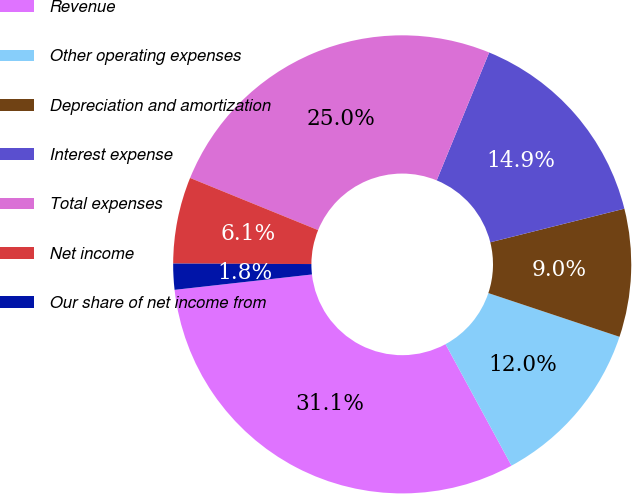<chart> <loc_0><loc_0><loc_500><loc_500><pie_chart><fcel>Revenue<fcel>Other operating expenses<fcel>Depreciation and amortization<fcel>Interest expense<fcel>Total expenses<fcel>Net income<fcel>Our share of net income from<nl><fcel>31.14%<fcel>11.96%<fcel>9.03%<fcel>14.89%<fcel>25.04%<fcel>6.1%<fcel>1.83%<nl></chart> 